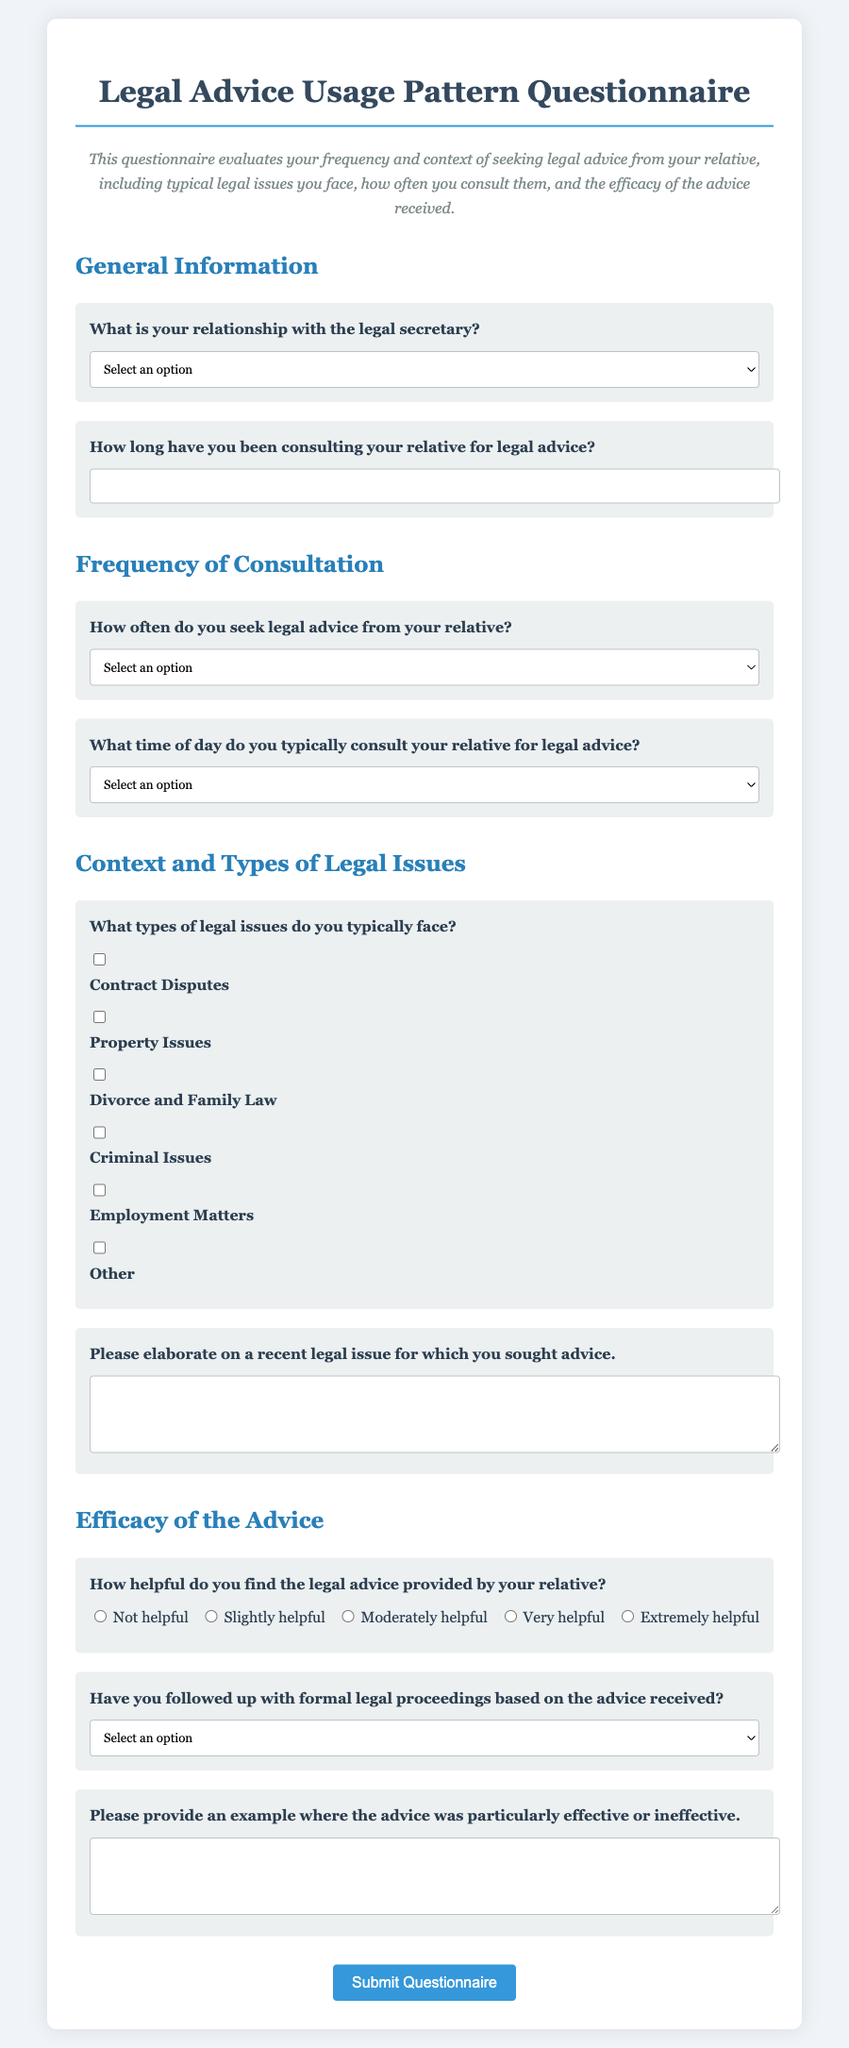What is the main purpose of the questionnaire? The main purpose is to evaluate the frequency and context of seeking legal advice from a relative.
Answer: Evaluate frequency and context of seeking legal advice How many types of legal issues are listed in the questionnaire? There are six types of legal issues provided in the document.
Answer: Six types What relationship options are available in the questionnaire? The relationship options are Sibling, Parent, Child, Cousin, and Other.
Answer: Sibling, Parent, Child, Cousin, Other What is the highest rating on the helpfulness scale? The highest rating on the helpfulness scale is five.
Answer: Five What time of day can you select for consulting? The options include Morning, Afternoon, Evening, Night, and No specific time.
Answer: Morning, Afternoon, Evening, Night, No specific time What type of legal issue is specifically mentioned with an option related to marriage? The option specifically related to marriage is Divorce and Family Law.
Answer: Divorce and Family Law 